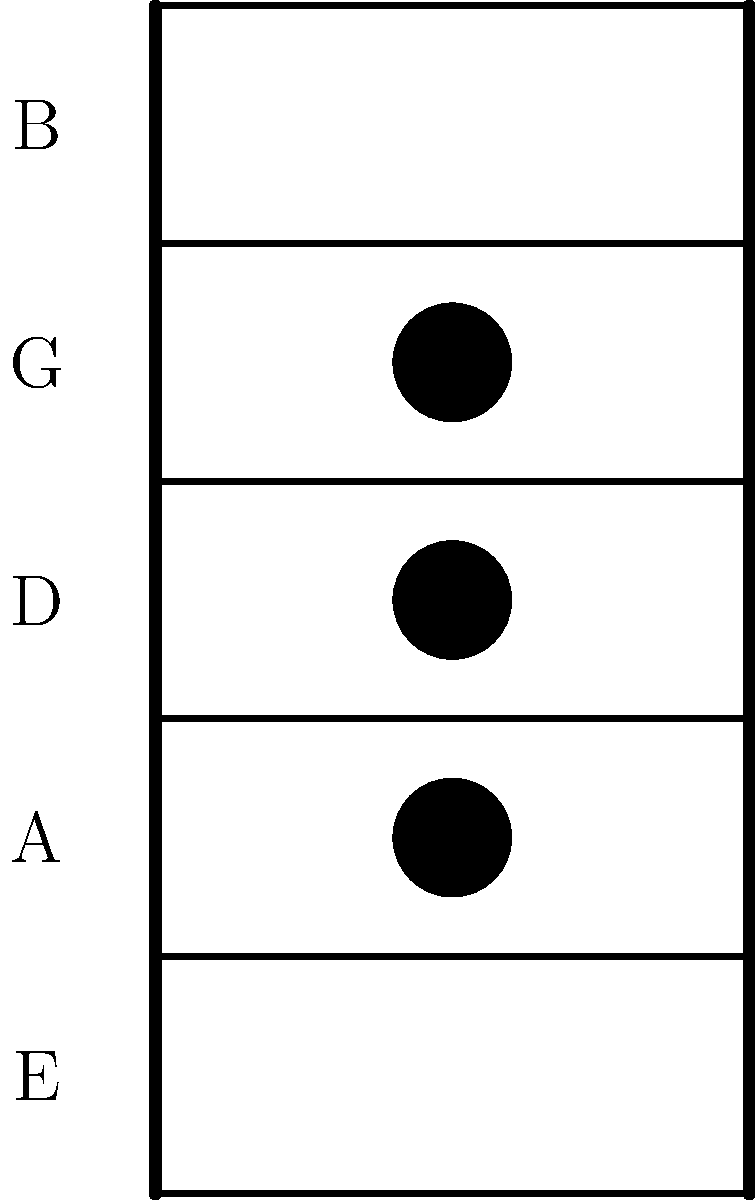As a country guitarist, you're working on a new song that requires a specific chord. Based on the chord diagram shown, which chord is being represented? Let's analyze the chord diagram step-by-step:

1. The diagram shows a portion of a guitar fretboard with 5 frets and 4 strings visible.

2. We can see three black dots, which represent finger positions:
   - One on the A string (2nd string from the bottom) at the 2nd fret
   - One on the D string (3rd string from the bottom) at the 2nd fret
   - One on the G string (4th string from the bottom) at the 2nd fret

3. The E string (lowest string) and B string (highest visible string) are not pressed, meaning they are played open.

4. This finger position corresponds to the D major chord:
   - Open E string (plays E note)
   - A string pressed at 2nd fret (plays D note)
   - D string pressed at 2nd fret (plays F# note)
   - G string pressed at 2nd fret (plays A note)
   - Open B string (plays B note)

5. The combination of these notes (D, F#, A) forms the D major triad, with the additional E and B notes adding fullness to the chord.

This chord is commonly used in country music and is essential for many popular country songs.
Answer: D major chord 